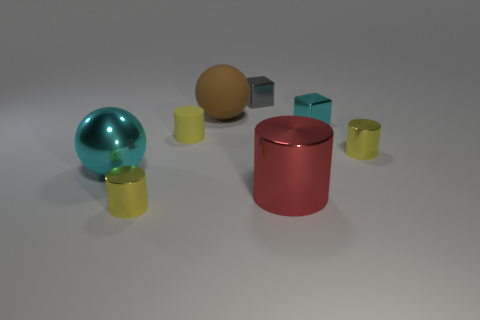How many yellow cylinders must be subtracted to get 1 yellow cylinders? 2 Subtract all red metallic cylinders. How many cylinders are left? 3 Subtract all red cylinders. How many cylinders are left? 3 Subtract 1 blocks. How many blocks are left? 1 Subtract all blocks. How many objects are left? 6 Add 1 yellow shiny objects. How many objects exist? 9 Subtract all purple cubes. How many yellow cylinders are left? 3 Subtract all cylinders. Subtract all tiny shiny things. How many objects are left? 0 Add 4 cyan metallic balls. How many cyan metallic balls are left? 5 Add 5 tiny gray cubes. How many tiny gray cubes exist? 6 